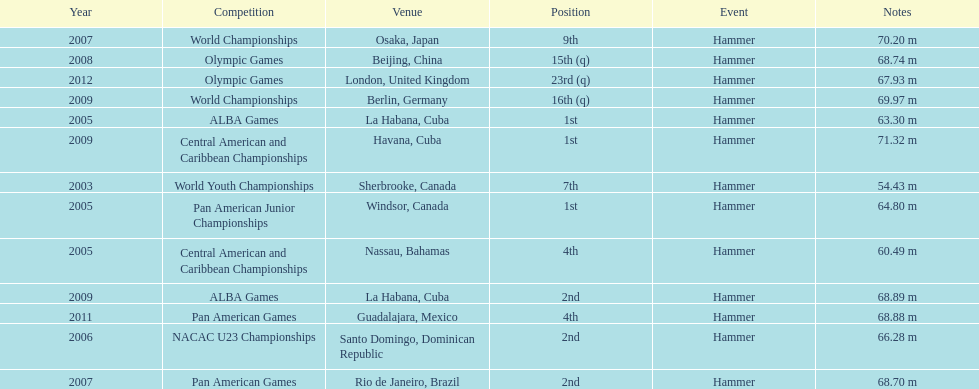Could you parse the entire table as a dict? {'header': ['Year', 'Competition', 'Venue', 'Position', 'Event', 'Notes'], 'rows': [['2007', 'World Championships', 'Osaka, Japan', '9th', 'Hammer', '70.20 m'], ['2008', 'Olympic Games', 'Beijing, China', '15th (q)', 'Hammer', '68.74 m'], ['2012', 'Olympic Games', 'London, United Kingdom', '23rd (q)', 'Hammer', '67.93 m'], ['2009', 'World Championships', 'Berlin, Germany', '16th (q)', 'Hammer', '69.97 m'], ['2005', 'ALBA Games', 'La Habana, Cuba', '1st', 'Hammer', '63.30 m'], ['2009', 'Central American and Caribbean Championships', 'Havana, Cuba', '1st', 'Hammer', '71.32 m'], ['2003', 'World Youth Championships', 'Sherbrooke, Canada', '7th', 'Hammer', '54.43 m'], ['2005', 'Pan American Junior Championships', 'Windsor, Canada', '1st', 'Hammer', '64.80 m'], ['2005', 'Central American and Caribbean Championships', 'Nassau, Bahamas', '4th', 'Hammer', '60.49 m'], ['2009', 'ALBA Games', 'La Habana, Cuba', '2nd', 'Hammer', '68.89 m'], ['2011', 'Pan American Games', 'Guadalajara, Mexico', '4th', 'Hammer', '68.88 m'], ['2006', 'NACAC U23 Championships', 'Santo Domingo, Dominican Republic', '2nd', 'Hammer', '66.28 m'], ['2007', 'Pan American Games', 'Rio de Janeiro, Brazil', '2nd', 'Hammer', '68.70 m']]} Does arasay thondike have more/less than 4 1st place tournament finishes? Less. 